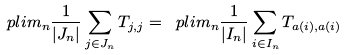<formula> <loc_0><loc_0><loc_500><loc_500>\ p l i m _ { n } \frac { 1 } { | J _ { n } | } \sum _ { j \in J _ { n } } T _ { j , j } = \ p l i m _ { n } \frac { 1 } { | I _ { n } | } \sum _ { i \in I _ { n } } T _ { a ( i ) , a ( i ) }</formula> 